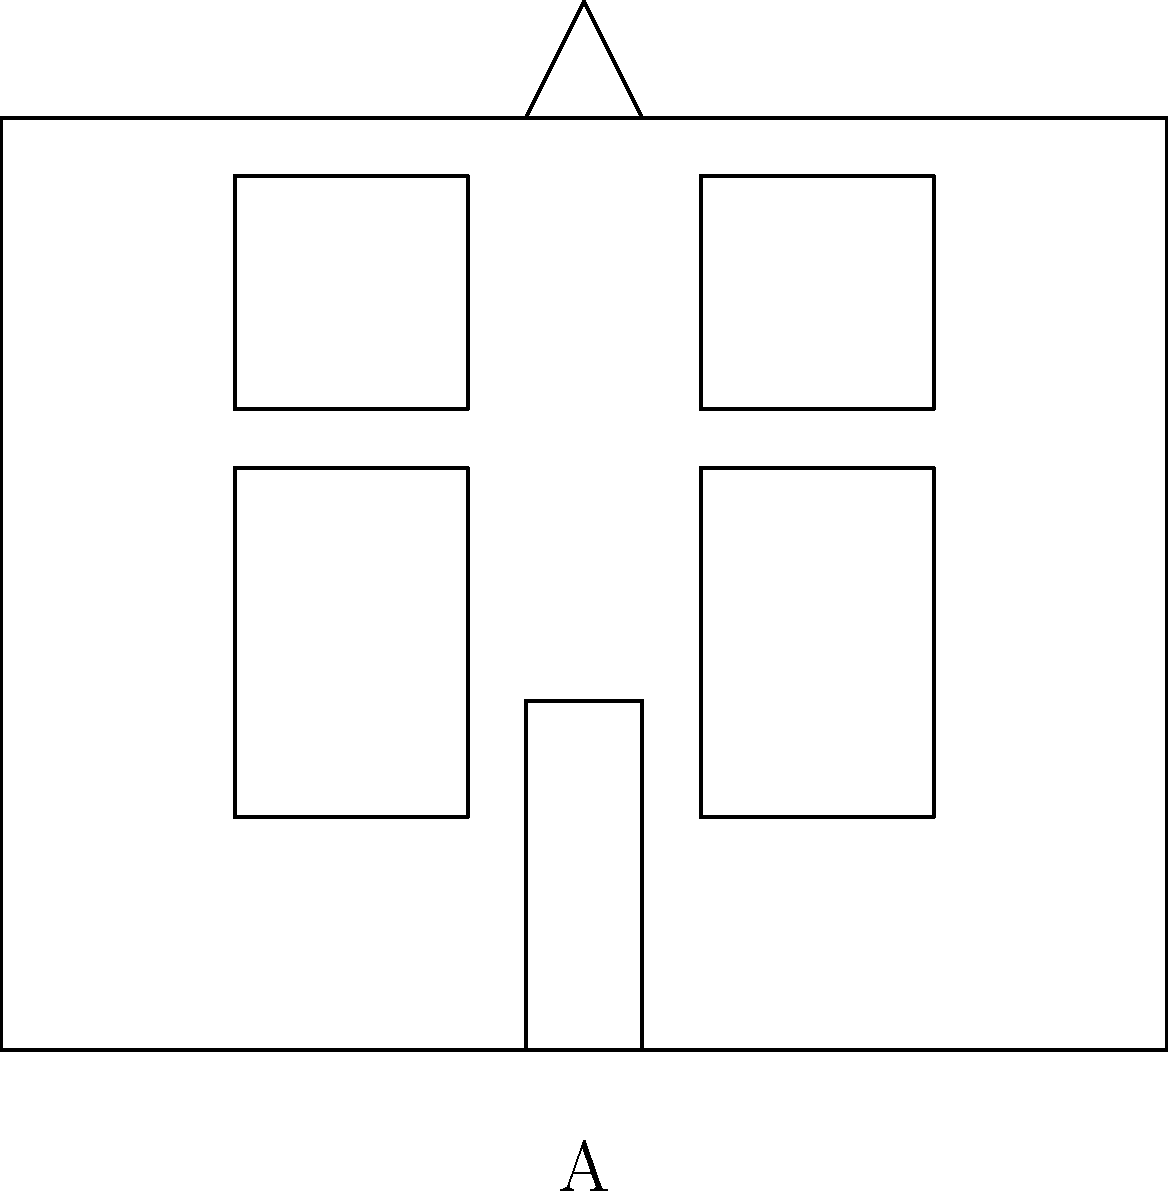As a retired history professor interested in purchasing a historic property, you come across two architectural sketches labeled A and B. Which of these sketches represents a Georgian style facade? To determine which sketch represents a Georgian style facade, let's analyze the key features of each:

Sketch A:
1. Symmetrical design with a central door
2. Two windows on each side of the door, evenly spaced
3. Five openings (windows and door) on the ground floor
4. Two windows on the second floor, aligned with the ground floor windows
5. Simple, rectangular shape
6. Small pediment above the door

Sketch B:
1. Columns extending to the roofline
2. Wide steps leading to the entrance
3. Prominent entablature (horizontal element supported by columns)
4. No visible individual windows

Georgian architecture is characterized by:
- Symmetry and balance
- Rectangular shape
- Central door with windows on either side
- Multiple panes in the windows
- Sometimes a small pediment above the door

Greek Revival architecture is characterized by:
- Columns extending to the roofline
- Low-pitched roof
- Prominent entablature
- Wide steps leading to the entrance

Based on these characteristics, Sketch A closely matches the Georgian style with its symmetrical design, central door, evenly spaced windows, and small pediment. Sketch B, with its columns and prominent entablature, represents a Greek Revival style.
Answer: A 